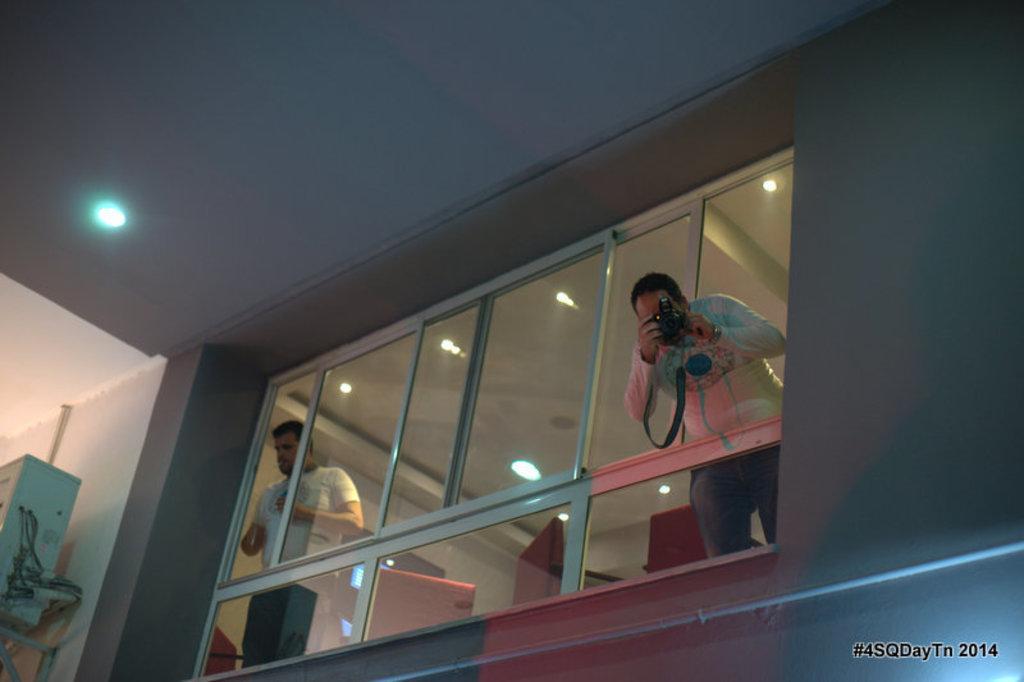Describe this image in one or two sentences. Here we can see two persons and he is holding a camera with his hands. This is wall and there are lights. Here we can see glasses, ceiling, and an object. 